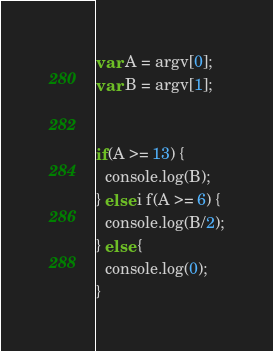Convert code to text. <code><loc_0><loc_0><loc_500><loc_500><_JavaScript_>var A = argv[0];
var B = argv[1];


if(A >= 13) {
  console.log(B);
} else i f(A >= 6) {
  console.log(B/2);
} else {
  console.log(0);
}
</code> 